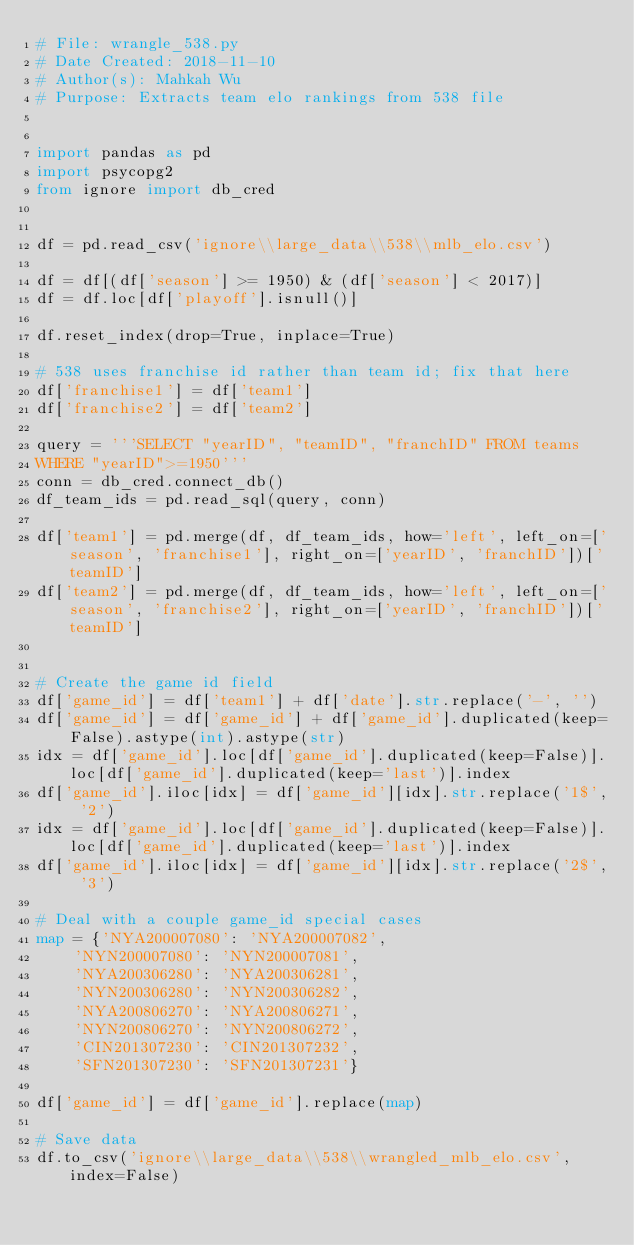Convert code to text. <code><loc_0><loc_0><loc_500><loc_500><_Python_># File: wrangle_538.py
# Date Created: 2018-11-10
# Author(s): Mahkah Wu
# Purpose: Extracts team elo rankings from 538 file


import pandas as pd
import psycopg2
from ignore import db_cred


df = pd.read_csv('ignore\\large_data\\538\\mlb_elo.csv')

df = df[(df['season'] >= 1950) & (df['season'] < 2017)]
df = df.loc[df['playoff'].isnull()]

df.reset_index(drop=True, inplace=True)

# 538 uses franchise id rather than team id; fix that here
df['franchise1'] = df['team1']
df['franchise2'] = df['team2']

query = '''SELECT "yearID", "teamID", "franchID" FROM teams
WHERE "yearID">=1950'''
conn = db_cred.connect_db()
df_team_ids = pd.read_sql(query, conn)

df['team1'] = pd.merge(df, df_team_ids, how='left', left_on=['season', 'franchise1'], right_on=['yearID', 'franchID'])['teamID']
df['team2'] = pd.merge(df, df_team_ids, how='left', left_on=['season', 'franchise2'], right_on=['yearID', 'franchID'])['teamID']


# Create the game id field
df['game_id'] = df['team1'] + df['date'].str.replace('-', '')
df['game_id'] = df['game_id'] + df['game_id'].duplicated(keep=False).astype(int).astype(str)
idx = df['game_id'].loc[df['game_id'].duplicated(keep=False)].loc[df['game_id'].duplicated(keep='last')].index
df['game_id'].iloc[idx] = df['game_id'][idx].str.replace('1$', '2')
idx = df['game_id'].loc[df['game_id'].duplicated(keep=False)].loc[df['game_id'].duplicated(keep='last')].index
df['game_id'].iloc[idx] = df['game_id'][idx].str.replace('2$', '3')

# Deal with a couple game_id special cases
map = {'NYA200007080': 'NYA200007082',
    'NYN200007080': 'NYN200007081',
    'NYA200306280': 'NYA200306281',
    'NYN200306280': 'NYN200306282',
    'NYA200806270': 'NYA200806271',
    'NYN200806270': 'NYN200806272',
    'CIN201307230': 'CIN201307232',
    'SFN201307230': 'SFN201307231'}

df['game_id'] = df['game_id'].replace(map)

# Save data
df.to_csv('ignore\\large_data\\538\\wrangled_mlb_elo.csv', index=False)
</code> 